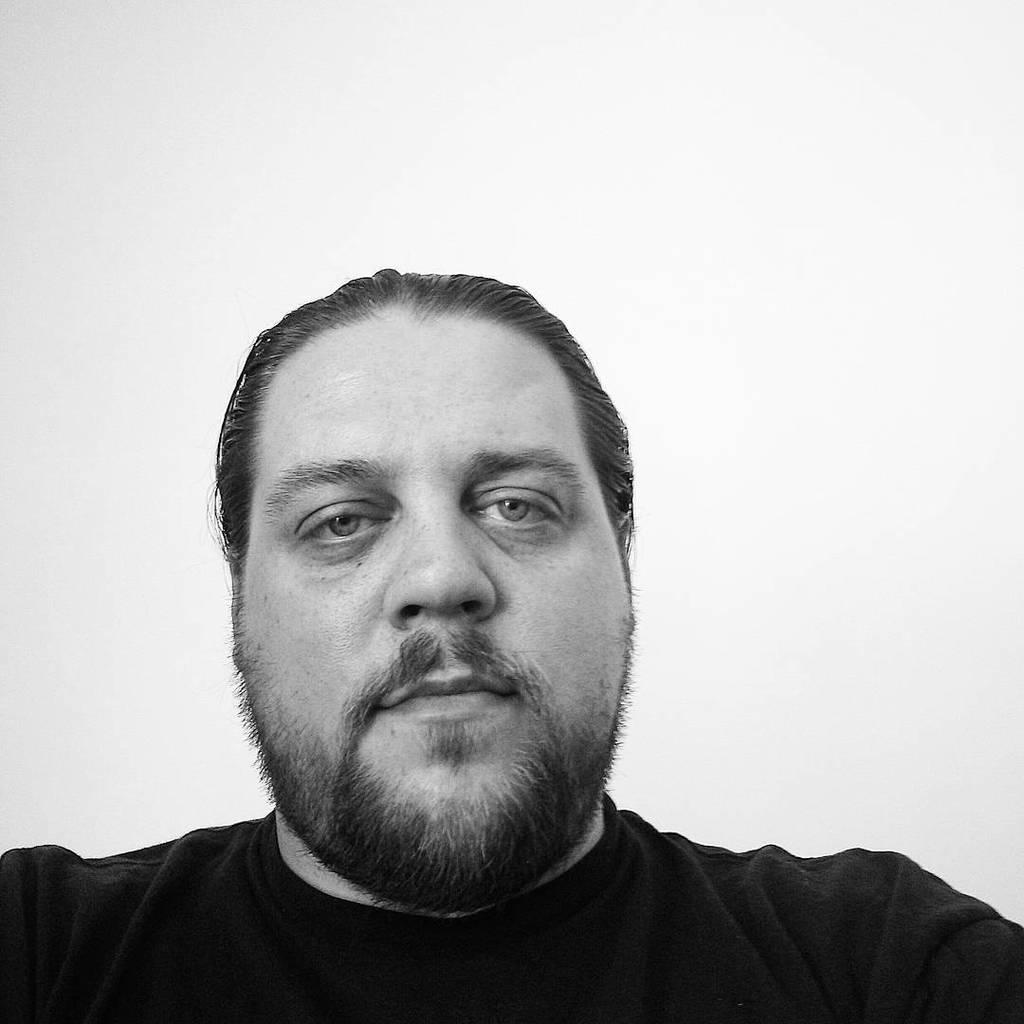Who or what is the main subject of the image? There is a person in the image. What is the person wearing in the image? The person is wearing a black t-shirt. What can be seen behind the person in the image? There is a wall behind the person. What type of hat is the person wearing in the image? There is no hat visible in the image; the person is wearing a black t-shirt. What kind of soup is being served in the image? There is no soup present in the image. 